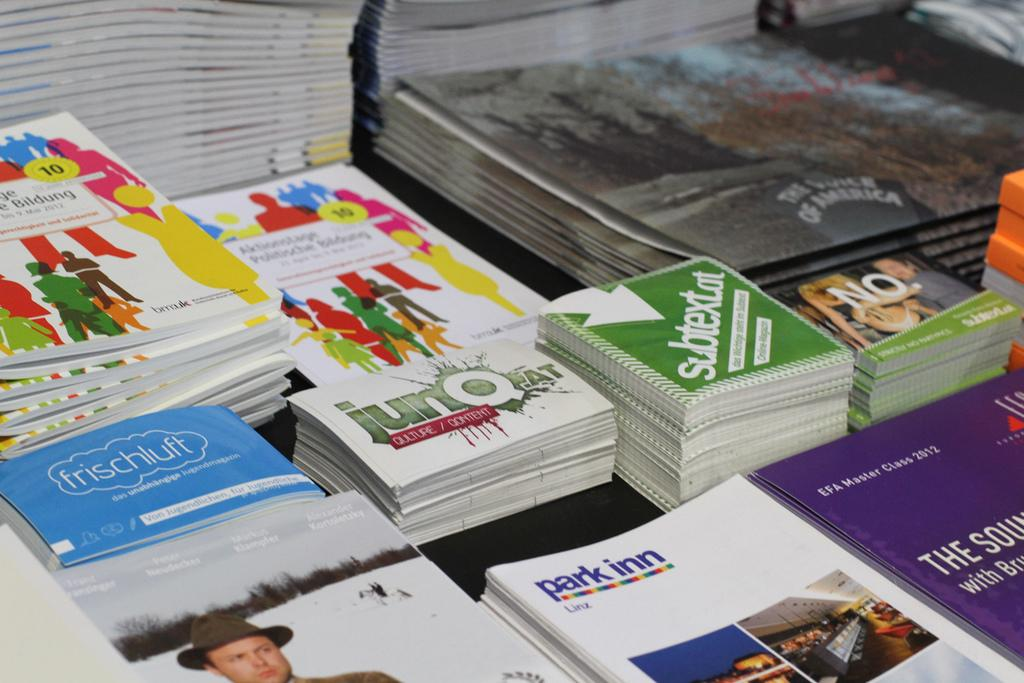<image>
Provide a brief description of the given image. Stacks of books include some labeled park inn. 